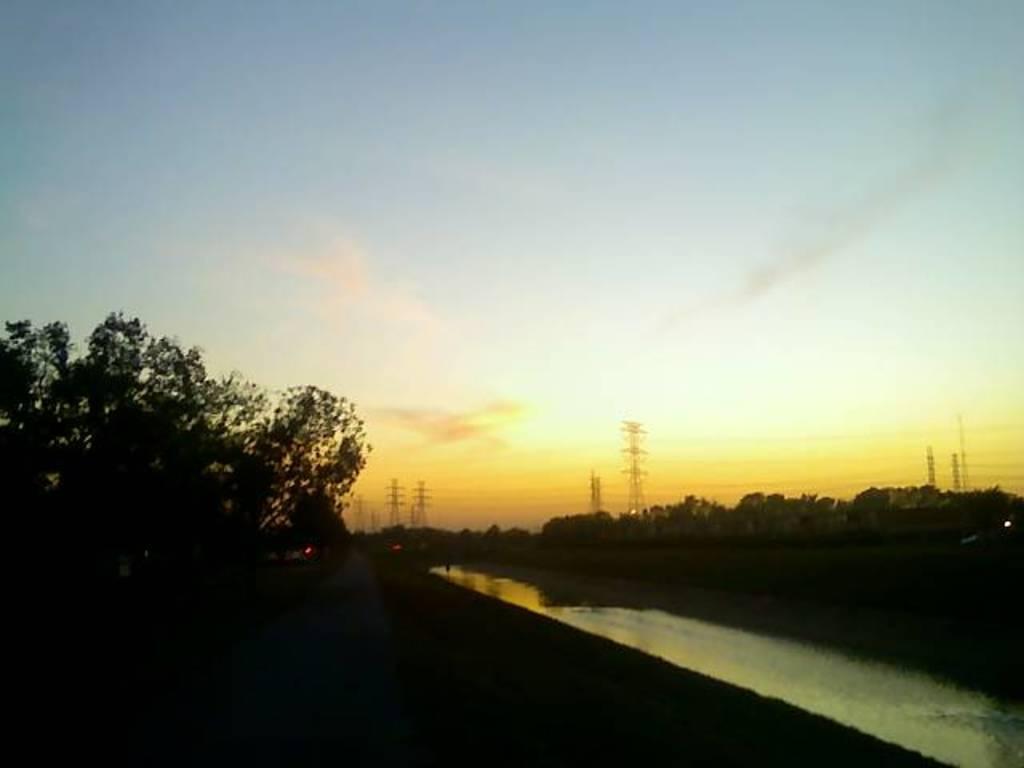In one or two sentences, can you explain what this image depicts? In this image, there are trees, transmission towers, wires, walkway and the water. At the bottom of the image, there is a dark view. There is the sky in the background. 